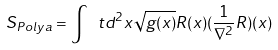<formula> <loc_0><loc_0><loc_500><loc_500>S _ { P o l y a } = \int \ t d ^ { 2 } x \sqrt { g ( x ) } R ( x ) ( \frac { 1 } { \nabla ^ { 2 } } R ) ( x )</formula> 